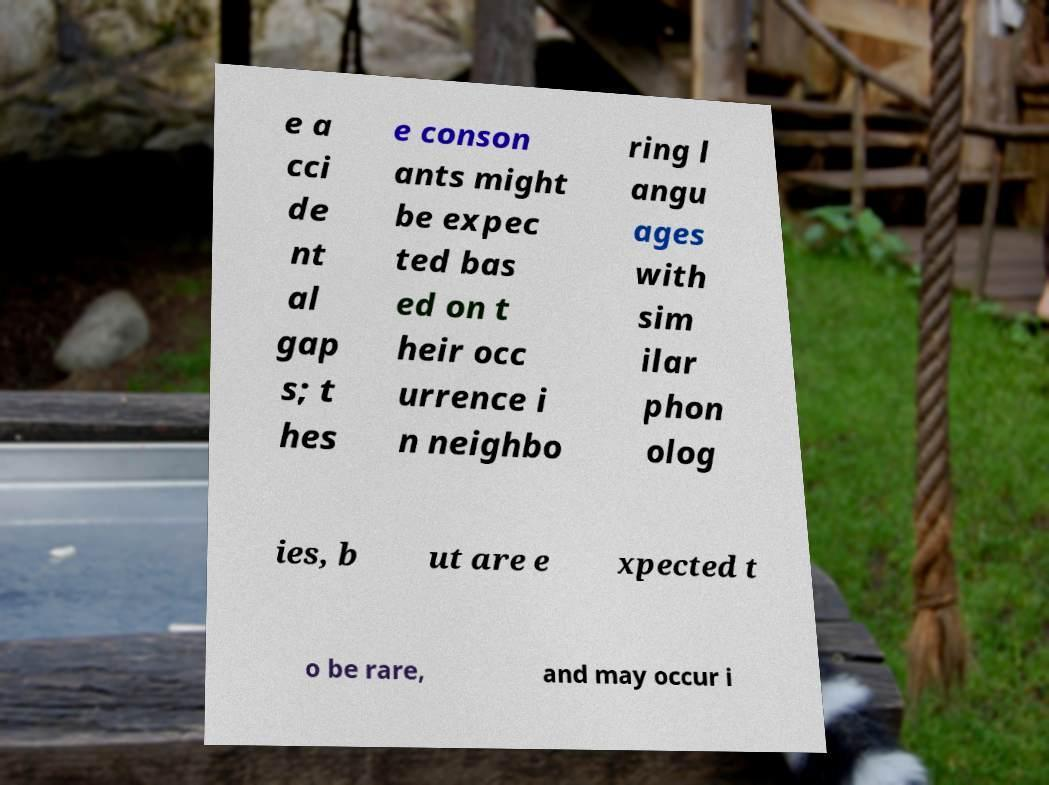What messages or text are displayed in this image? I need them in a readable, typed format. e a cci de nt al gap s; t hes e conson ants might be expec ted bas ed on t heir occ urrence i n neighbo ring l angu ages with sim ilar phon olog ies, b ut are e xpected t o be rare, and may occur i 